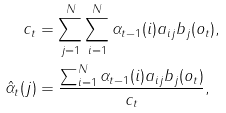Convert formula to latex. <formula><loc_0><loc_0><loc_500><loc_500>c _ { t } & = \sum _ { j = 1 } ^ { N } \sum _ { i = 1 } ^ { N } \alpha _ { t - 1 } ( i ) a _ { i j } b _ { j } ( o _ { t } ) , \\ \hat { \alpha } _ { t } ( j ) & = \frac { \sum _ { i = 1 } ^ { N } \alpha _ { t - 1 } ( i ) a _ { i j } b _ { j } ( o _ { t } ) } { c _ { t } } ,</formula> 